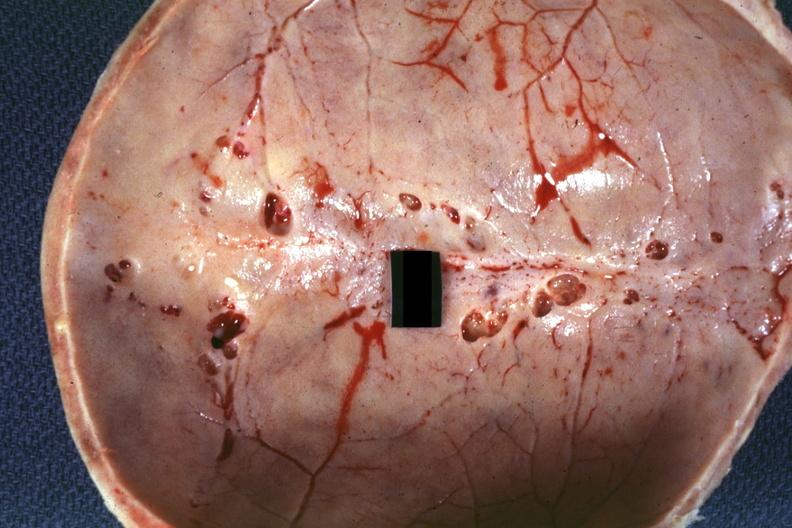what does this image show?
Answer the question using a single word or phrase. Inner table view multiple venous lakes 